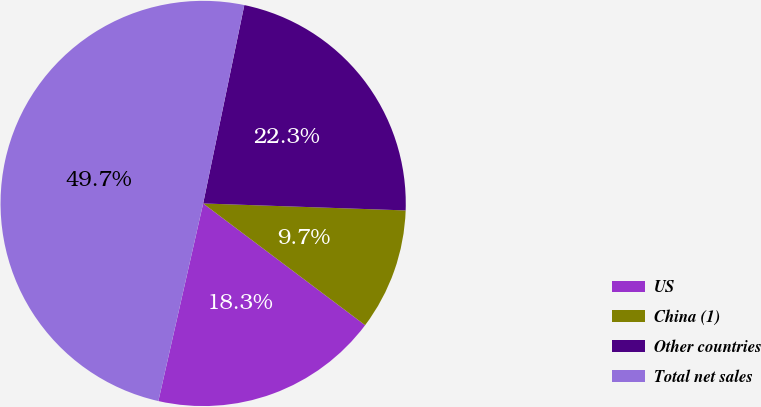Convert chart. <chart><loc_0><loc_0><loc_500><loc_500><pie_chart><fcel>US<fcel>China (1)<fcel>Other countries<fcel>Total net sales<nl><fcel>18.29%<fcel>9.71%<fcel>22.29%<fcel>49.71%<nl></chart> 